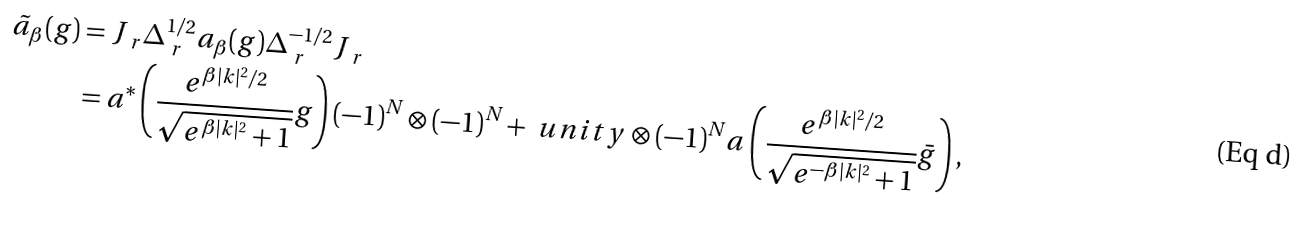<formula> <loc_0><loc_0><loc_500><loc_500>\tilde { a } _ { \beta } ( g ) & = J _ { \ r } \Delta _ { \ r } ^ { 1 / 2 } a _ { \beta } ( g ) \Delta _ { \ r } ^ { - 1 / 2 } J _ { \ r } \\ & = a ^ { * } \left ( \frac { e ^ { \beta | k | ^ { 2 } / 2 } } { \sqrt { e ^ { \beta | k | ^ { 2 } } + 1 } } g \right ) ( - 1 ) ^ { N } \otimes ( - 1 ) ^ { N } + \ u n i t y \otimes ( - 1 ) ^ { N } a \left ( \frac { e ^ { \beta | k | ^ { 2 } / 2 } } { \sqrt { e ^ { - \beta | k | ^ { 2 } } + 1 } } \bar { g } \right ) ,</formula> 